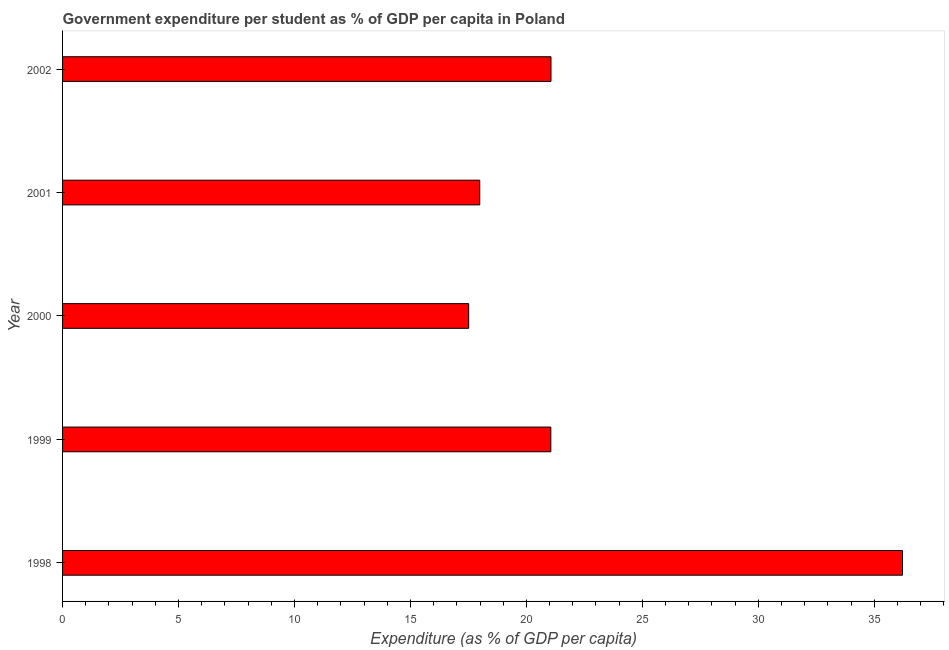Does the graph contain any zero values?
Offer a terse response. No. Does the graph contain grids?
Provide a short and direct response. No. What is the title of the graph?
Ensure brevity in your answer.  Government expenditure per student as % of GDP per capita in Poland. What is the label or title of the X-axis?
Offer a terse response. Expenditure (as % of GDP per capita). What is the label or title of the Y-axis?
Your response must be concise. Year. What is the government expenditure per student in 1999?
Your answer should be compact. 21.05. Across all years, what is the maximum government expenditure per student?
Ensure brevity in your answer.  36.22. Across all years, what is the minimum government expenditure per student?
Provide a short and direct response. 17.51. In which year was the government expenditure per student maximum?
Your answer should be very brief. 1998. In which year was the government expenditure per student minimum?
Ensure brevity in your answer.  2000. What is the sum of the government expenditure per student?
Offer a terse response. 113.83. What is the difference between the government expenditure per student in 1998 and 1999?
Offer a very short reply. 15.16. What is the average government expenditure per student per year?
Your answer should be very brief. 22.77. What is the median government expenditure per student?
Your response must be concise. 21.05. What is the ratio of the government expenditure per student in 1998 to that in 2001?
Keep it short and to the point. 2.01. Is the difference between the government expenditure per student in 1998 and 2000 greater than the difference between any two years?
Ensure brevity in your answer.  Yes. What is the difference between the highest and the second highest government expenditure per student?
Provide a succinct answer. 15.16. Is the sum of the government expenditure per student in 2001 and 2002 greater than the maximum government expenditure per student across all years?
Ensure brevity in your answer.  Yes. In how many years, is the government expenditure per student greater than the average government expenditure per student taken over all years?
Offer a terse response. 1. Are all the bars in the graph horizontal?
Your answer should be very brief. Yes. How many years are there in the graph?
Offer a terse response. 5. What is the Expenditure (as % of GDP per capita) of 1998?
Your answer should be compact. 36.22. What is the Expenditure (as % of GDP per capita) of 1999?
Your answer should be very brief. 21.05. What is the Expenditure (as % of GDP per capita) in 2000?
Your response must be concise. 17.51. What is the Expenditure (as % of GDP per capita) of 2001?
Make the answer very short. 17.99. What is the Expenditure (as % of GDP per capita) in 2002?
Provide a short and direct response. 21.06. What is the difference between the Expenditure (as % of GDP per capita) in 1998 and 1999?
Give a very brief answer. 15.16. What is the difference between the Expenditure (as % of GDP per capita) in 1998 and 2000?
Offer a terse response. 18.7. What is the difference between the Expenditure (as % of GDP per capita) in 1998 and 2001?
Keep it short and to the point. 18.23. What is the difference between the Expenditure (as % of GDP per capita) in 1998 and 2002?
Offer a terse response. 15.16. What is the difference between the Expenditure (as % of GDP per capita) in 1999 and 2000?
Your answer should be compact. 3.54. What is the difference between the Expenditure (as % of GDP per capita) in 1999 and 2001?
Provide a succinct answer. 3.06. What is the difference between the Expenditure (as % of GDP per capita) in 1999 and 2002?
Give a very brief answer. -0.01. What is the difference between the Expenditure (as % of GDP per capita) in 2000 and 2001?
Your answer should be compact. -0.48. What is the difference between the Expenditure (as % of GDP per capita) in 2000 and 2002?
Provide a short and direct response. -3.55. What is the difference between the Expenditure (as % of GDP per capita) in 2001 and 2002?
Offer a very short reply. -3.07. What is the ratio of the Expenditure (as % of GDP per capita) in 1998 to that in 1999?
Give a very brief answer. 1.72. What is the ratio of the Expenditure (as % of GDP per capita) in 1998 to that in 2000?
Offer a very short reply. 2.07. What is the ratio of the Expenditure (as % of GDP per capita) in 1998 to that in 2001?
Your answer should be very brief. 2.01. What is the ratio of the Expenditure (as % of GDP per capita) in 1998 to that in 2002?
Make the answer very short. 1.72. What is the ratio of the Expenditure (as % of GDP per capita) in 1999 to that in 2000?
Offer a very short reply. 1.2. What is the ratio of the Expenditure (as % of GDP per capita) in 1999 to that in 2001?
Your answer should be compact. 1.17. What is the ratio of the Expenditure (as % of GDP per capita) in 2000 to that in 2002?
Provide a short and direct response. 0.83. What is the ratio of the Expenditure (as % of GDP per capita) in 2001 to that in 2002?
Make the answer very short. 0.85. 